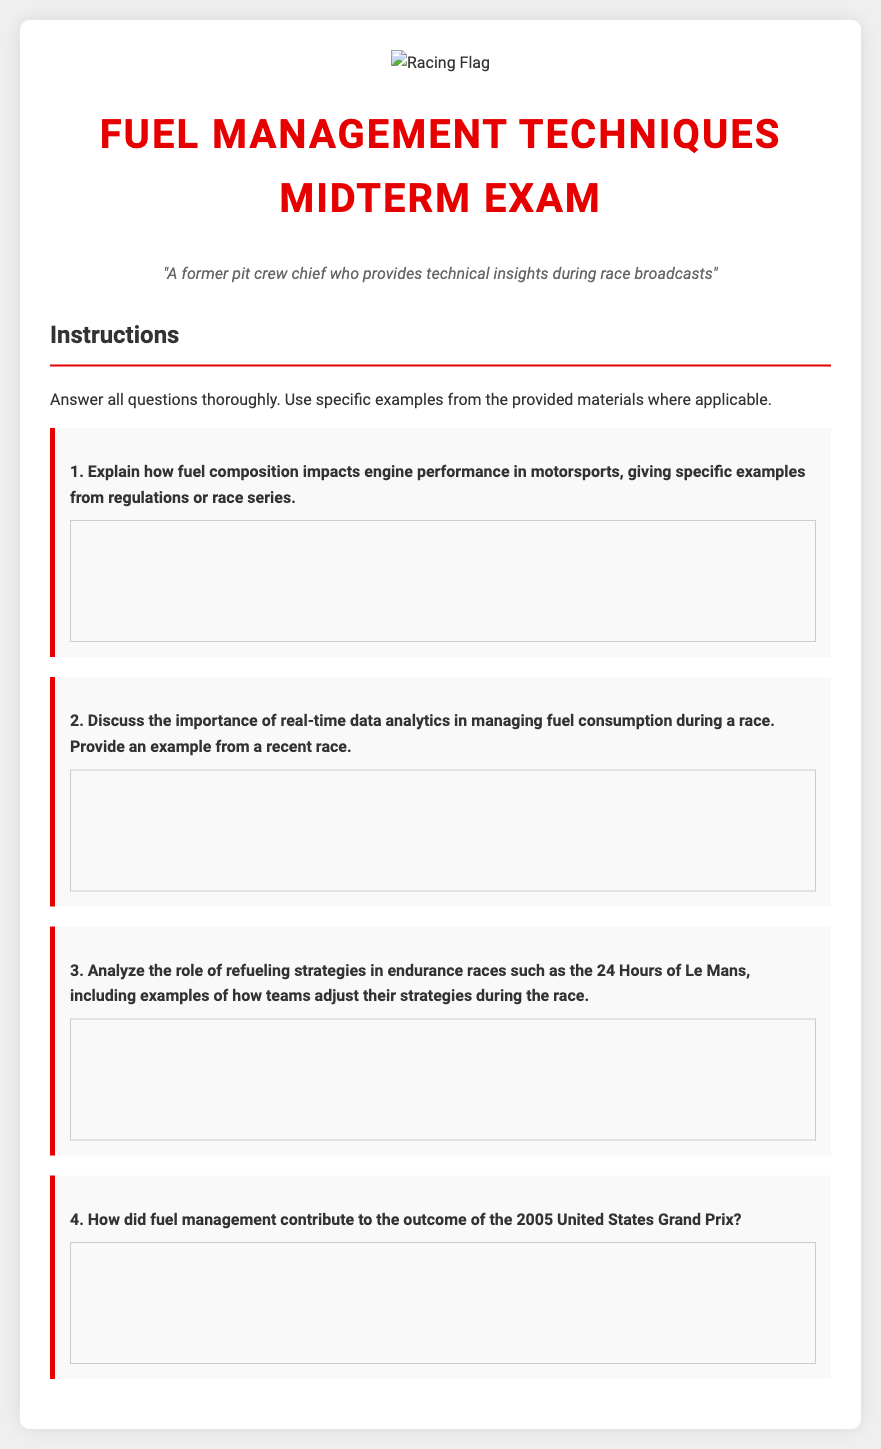What is the title of the document? The title of the document is presented prominently at the top of the page.
Answer: Fuel Management Techniques Midterm Exam What is the persona of the document? The persona is stated in a specific format, indicating the background of the individual.
Answer: A former pit crew chief who provides technical insights during race broadcasts How many questions are in the exam? The number of questions can be counted directly from the document.
Answer: 4 What is the first question about? The content of the first question provides insight into fuel composition's impact.
Answer: Fuel composition impacts engine performance in motorsports Which endurance race is mentioned in the document? The endurance race is specifically referenced in one of the questions of the exam.
Answer: 24 Hours of Le Mans In which year did the United States Grand Prix mentioned in the document take place? The date is specified within the content of the questions listed.
Answer: 2005 